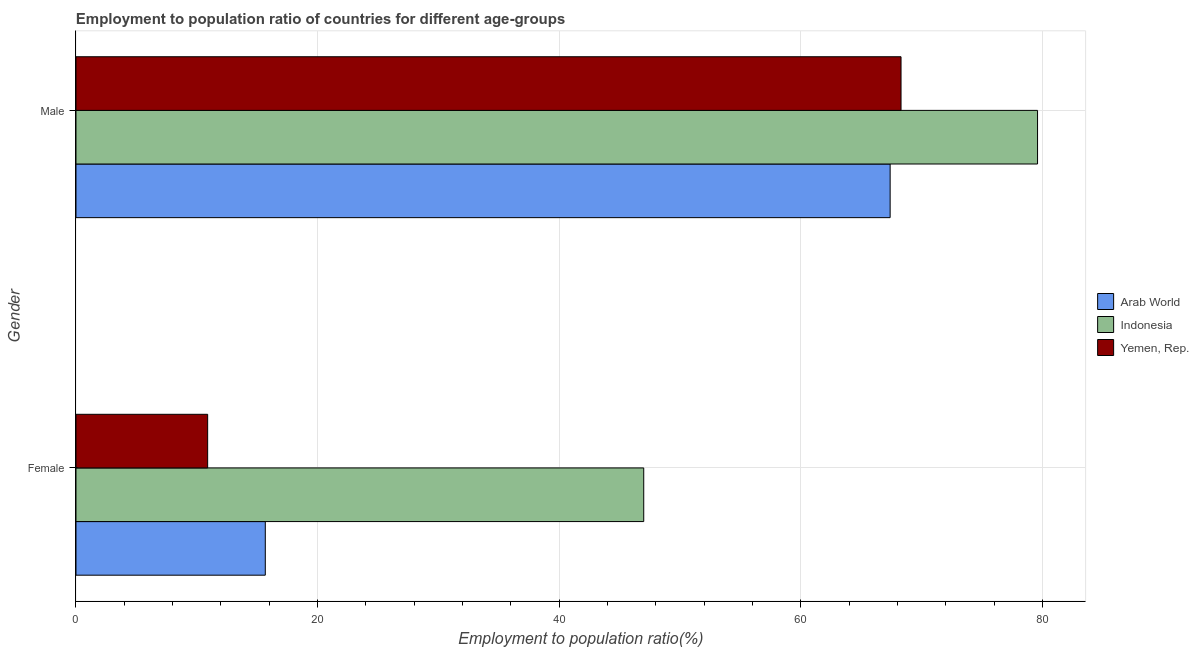How many different coloured bars are there?
Offer a terse response. 3. How many groups of bars are there?
Offer a terse response. 2. Are the number of bars per tick equal to the number of legend labels?
Keep it short and to the point. Yes. Are the number of bars on each tick of the Y-axis equal?
Your response must be concise. Yes. How many bars are there on the 2nd tick from the top?
Your response must be concise. 3. How many bars are there on the 2nd tick from the bottom?
Your answer should be very brief. 3. What is the employment to population ratio(male) in Yemen, Rep.?
Your answer should be very brief. 68.3. Across all countries, what is the maximum employment to population ratio(male)?
Provide a short and direct response. 79.6. Across all countries, what is the minimum employment to population ratio(female)?
Offer a very short reply. 10.9. In which country was the employment to population ratio(female) maximum?
Give a very brief answer. Indonesia. In which country was the employment to population ratio(female) minimum?
Make the answer very short. Yemen, Rep. What is the total employment to population ratio(male) in the graph?
Offer a very short reply. 215.3. What is the difference between the employment to population ratio(male) in Yemen, Rep. and that in Indonesia?
Make the answer very short. -11.3. What is the difference between the employment to population ratio(female) in Indonesia and the employment to population ratio(male) in Arab World?
Your response must be concise. -20.4. What is the average employment to population ratio(male) per country?
Your response must be concise. 71.77. What is the difference between the employment to population ratio(female) and employment to population ratio(male) in Yemen, Rep.?
Keep it short and to the point. -57.4. In how many countries, is the employment to population ratio(female) greater than 52 %?
Offer a very short reply. 0. What is the ratio of the employment to population ratio(female) in Arab World to that in Yemen, Rep.?
Your answer should be compact. 1.44. What does the 1st bar from the top in Male represents?
Offer a very short reply. Yemen, Rep. What does the 3rd bar from the bottom in Male represents?
Provide a succinct answer. Yemen, Rep. How many bars are there?
Ensure brevity in your answer.  6. Are all the bars in the graph horizontal?
Provide a short and direct response. Yes. What is the difference between two consecutive major ticks on the X-axis?
Ensure brevity in your answer.  20. Are the values on the major ticks of X-axis written in scientific E-notation?
Give a very brief answer. No. Does the graph contain any zero values?
Provide a succinct answer. No. Where does the legend appear in the graph?
Ensure brevity in your answer.  Center right. How are the legend labels stacked?
Provide a succinct answer. Vertical. What is the title of the graph?
Provide a short and direct response. Employment to population ratio of countries for different age-groups. What is the Employment to population ratio(%) of Arab World in Female?
Your answer should be very brief. 15.67. What is the Employment to population ratio(%) of Indonesia in Female?
Provide a short and direct response. 47. What is the Employment to population ratio(%) of Yemen, Rep. in Female?
Provide a short and direct response. 10.9. What is the Employment to population ratio(%) of Arab World in Male?
Offer a terse response. 67.4. What is the Employment to population ratio(%) of Indonesia in Male?
Your answer should be very brief. 79.6. What is the Employment to population ratio(%) of Yemen, Rep. in Male?
Provide a succinct answer. 68.3. Across all Gender, what is the maximum Employment to population ratio(%) in Arab World?
Your response must be concise. 67.4. Across all Gender, what is the maximum Employment to population ratio(%) in Indonesia?
Ensure brevity in your answer.  79.6. Across all Gender, what is the maximum Employment to population ratio(%) in Yemen, Rep.?
Offer a terse response. 68.3. Across all Gender, what is the minimum Employment to population ratio(%) of Arab World?
Make the answer very short. 15.67. Across all Gender, what is the minimum Employment to population ratio(%) of Yemen, Rep.?
Your answer should be very brief. 10.9. What is the total Employment to population ratio(%) of Arab World in the graph?
Keep it short and to the point. 83.07. What is the total Employment to population ratio(%) in Indonesia in the graph?
Provide a succinct answer. 126.6. What is the total Employment to population ratio(%) of Yemen, Rep. in the graph?
Your response must be concise. 79.2. What is the difference between the Employment to population ratio(%) of Arab World in Female and that in Male?
Make the answer very short. -51.73. What is the difference between the Employment to population ratio(%) of Indonesia in Female and that in Male?
Your answer should be very brief. -32.6. What is the difference between the Employment to population ratio(%) in Yemen, Rep. in Female and that in Male?
Provide a succinct answer. -57.4. What is the difference between the Employment to population ratio(%) in Arab World in Female and the Employment to population ratio(%) in Indonesia in Male?
Provide a succinct answer. -63.93. What is the difference between the Employment to population ratio(%) of Arab World in Female and the Employment to population ratio(%) of Yemen, Rep. in Male?
Offer a terse response. -52.63. What is the difference between the Employment to population ratio(%) in Indonesia in Female and the Employment to population ratio(%) in Yemen, Rep. in Male?
Give a very brief answer. -21.3. What is the average Employment to population ratio(%) in Arab World per Gender?
Offer a terse response. 41.54. What is the average Employment to population ratio(%) of Indonesia per Gender?
Make the answer very short. 63.3. What is the average Employment to population ratio(%) of Yemen, Rep. per Gender?
Your answer should be compact. 39.6. What is the difference between the Employment to population ratio(%) of Arab World and Employment to population ratio(%) of Indonesia in Female?
Your response must be concise. -31.33. What is the difference between the Employment to population ratio(%) of Arab World and Employment to population ratio(%) of Yemen, Rep. in Female?
Offer a terse response. 4.77. What is the difference between the Employment to population ratio(%) of Indonesia and Employment to population ratio(%) of Yemen, Rep. in Female?
Offer a terse response. 36.1. What is the difference between the Employment to population ratio(%) of Arab World and Employment to population ratio(%) of Indonesia in Male?
Your response must be concise. -12.2. What is the difference between the Employment to population ratio(%) of Arab World and Employment to population ratio(%) of Yemen, Rep. in Male?
Provide a short and direct response. -0.9. What is the ratio of the Employment to population ratio(%) in Arab World in Female to that in Male?
Provide a succinct answer. 0.23. What is the ratio of the Employment to population ratio(%) of Indonesia in Female to that in Male?
Offer a very short reply. 0.59. What is the ratio of the Employment to population ratio(%) of Yemen, Rep. in Female to that in Male?
Your response must be concise. 0.16. What is the difference between the highest and the second highest Employment to population ratio(%) of Arab World?
Provide a succinct answer. 51.73. What is the difference between the highest and the second highest Employment to population ratio(%) of Indonesia?
Provide a succinct answer. 32.6. What is the difference between the highest and the second highest Employment to population ratio(%) in Yemen, Rep.?
Provide a succinct answer. 57.4. What is the difference between the highest and the lowest Employment to population ratio(%) of Arab World?
Your answer should be very brief. 51.73. What is the difference between the highest and the lowest Employment to population ratio(%) in Indonesia?
Keep it short and to the point. 32.6. What is the difference between the highest and the lowest Employment to population ratio(%) in Yemen, Rep.?
Provide a succinct answer. 57.4. 